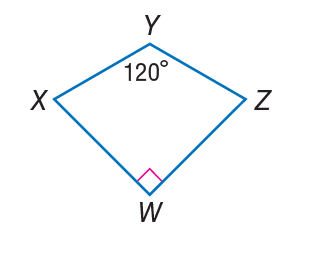Answer the mathemtical geometry problem and directly provide the correct option letter.
Question: If W X Y Z is a kite, find m \angle Z.
Choices: A: 60 B: 75 C: 120 D: 150 B 